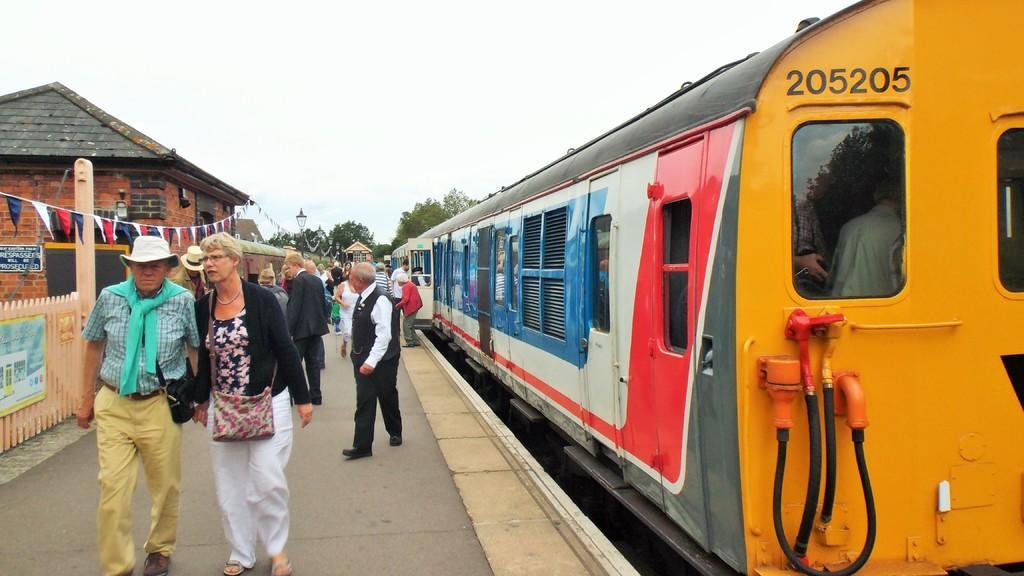In one or two sentences, can you explain what this image depicts? In this picture, we can see a few people on the platform, we can see the train, fencing, small flags, house, trees, lights, and the sky. 